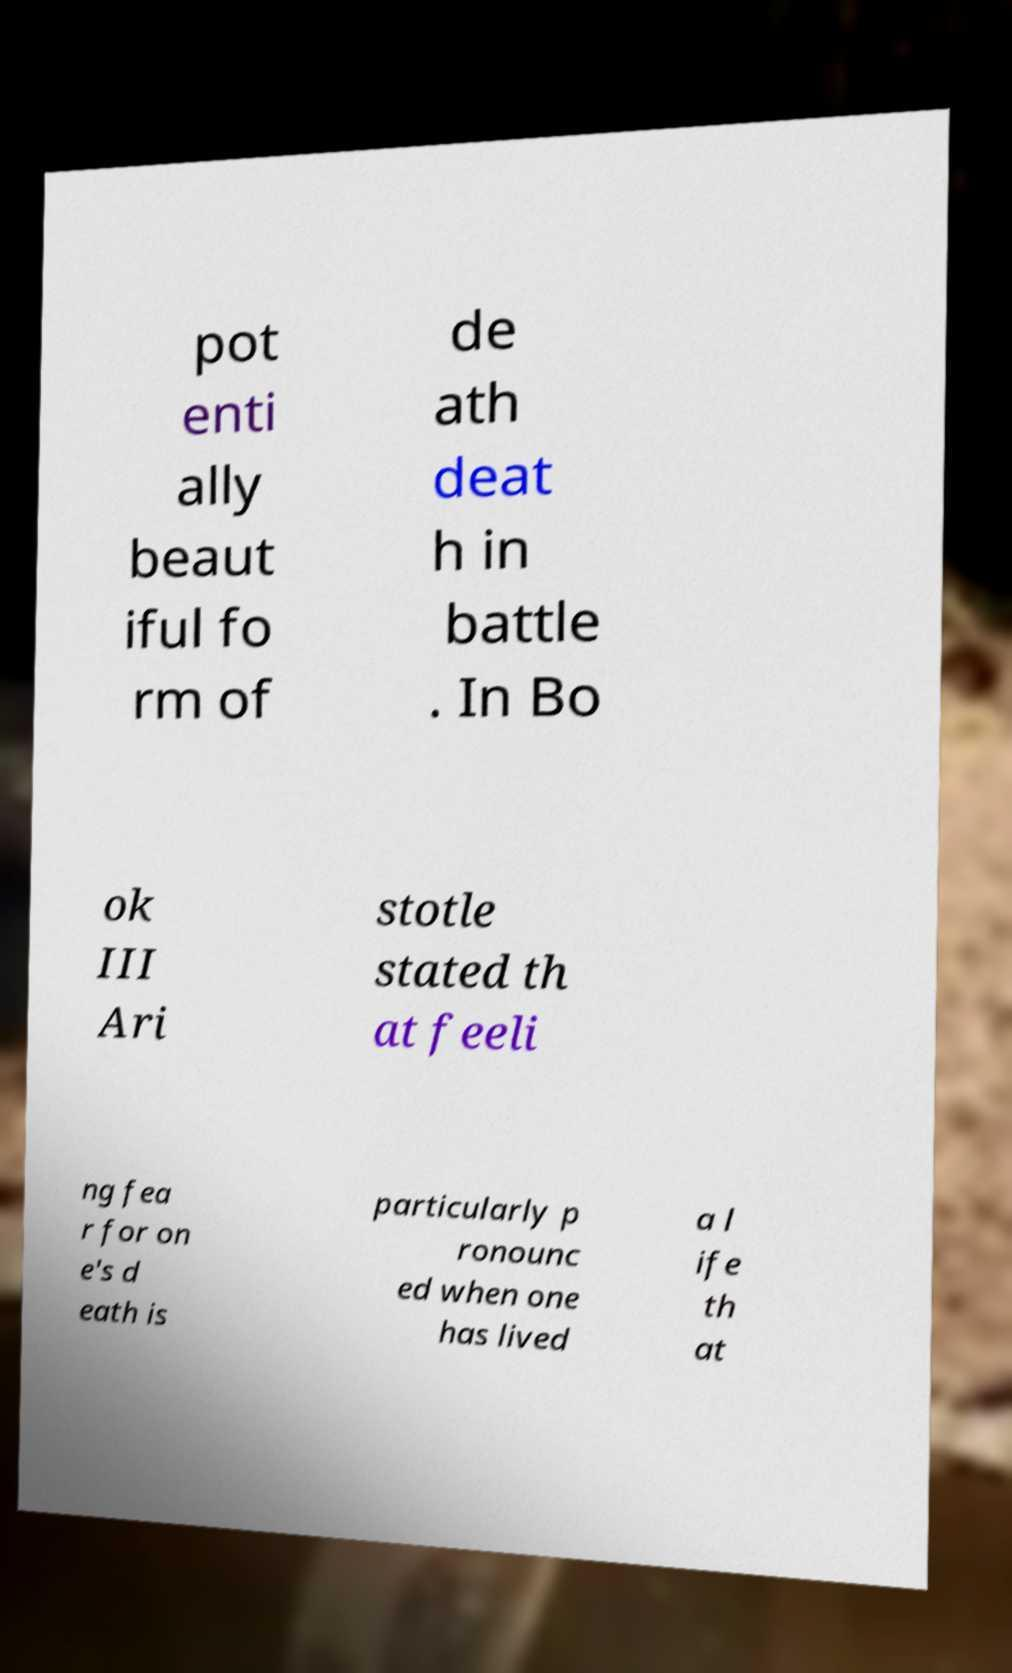For documentation purposes, I need the text within this image transcribed. Could you provide that? pot enti ally beaut iful fo rm of de ath deat h in battle . In Bo ok III Ari stotle stated th at feeli ng fea r for on e's d eath is particularly p ronounc ed when one has lived a l ife th at 